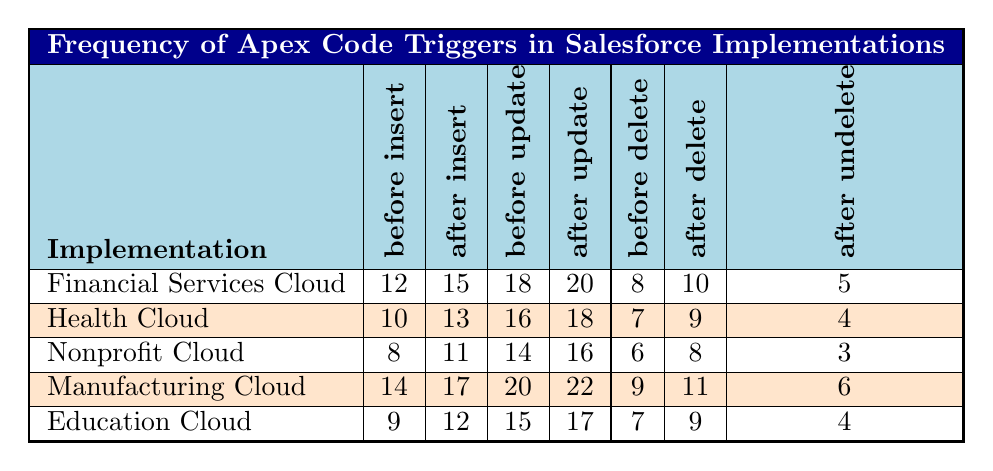What is the frequency of "before update" triggers in the Manufacturing Cloud? Referring to the table, the frequency of "before update" triggers in the Manufacturing Cloud is reported as 20.
Answer: 20 Which implementation has the highest number of "after insert" triggers? By examining the table, the Manufacturing Cloud has the highest number of "after insert" triggers with a frequency of 17.
Answer: Manufacturing Cloud How many total triggers are there for the Health Cloud? To find the total triggers for the Health Cloud, sum the frequency of all trigger types: 10 + 13 + 16 + 18 + 7 + 9 + 4 = 77.
Answer: 77 Is there a difference in "after update" trigger frequency between Financial Services Cloud and Education Cloud? The "after update" frequency for Financial Services Cloud is 20, while for Education Cloud it is 17. The difference is 20 - 17 = 3.
Answer: Yes What is the average number of "before delete" triggers across all implementations? Sum the "before delete" triggers: 8 + 7 + 6 + 9 + 7 = 37. There are 5 implementations, so the average is 37 / 5 = 7.4.
Answer: 7.4 In which cloud implementation are "after undelete" triggers least frequent? The least frequency for "after undelete" triggers is found in the Nonprofit Cloud, where it shows a frequency of 3.
Answer: Nonprofit Cloud How many more "after delete" triggers does the Manufacturing Cloud have than the Health Cloud? The "after delete" frequency for Manufacturing Cloud is 11 and for Health Cloud is 9. The difference is 11 - 9 = 2.
Answer: 2 What is the total frequency of "insert" triggers (both before and after) for Education Cloud? For Education Cloud, "before insert" is 9 and "after insert" is 12. So, the total is 9 + 12 = 21.
Answer: 21 Which cloud implementation has the highest frequency of "before insert" triggers? The Manufacturing Cloud has the highest frequency of "before insert" triggers at 14, according to the table.
Answer: Manufacturing Cloud Is the total frequency of "before delete" triggers higher in Financial Services Cloud than in Nonprofit Cloud? Financial Services Cloud has 8 "before delete" triggers, while Nonprofit Cloud has 6. Yes, Financial Services Cloud has a higher total.
Answer: Yes 